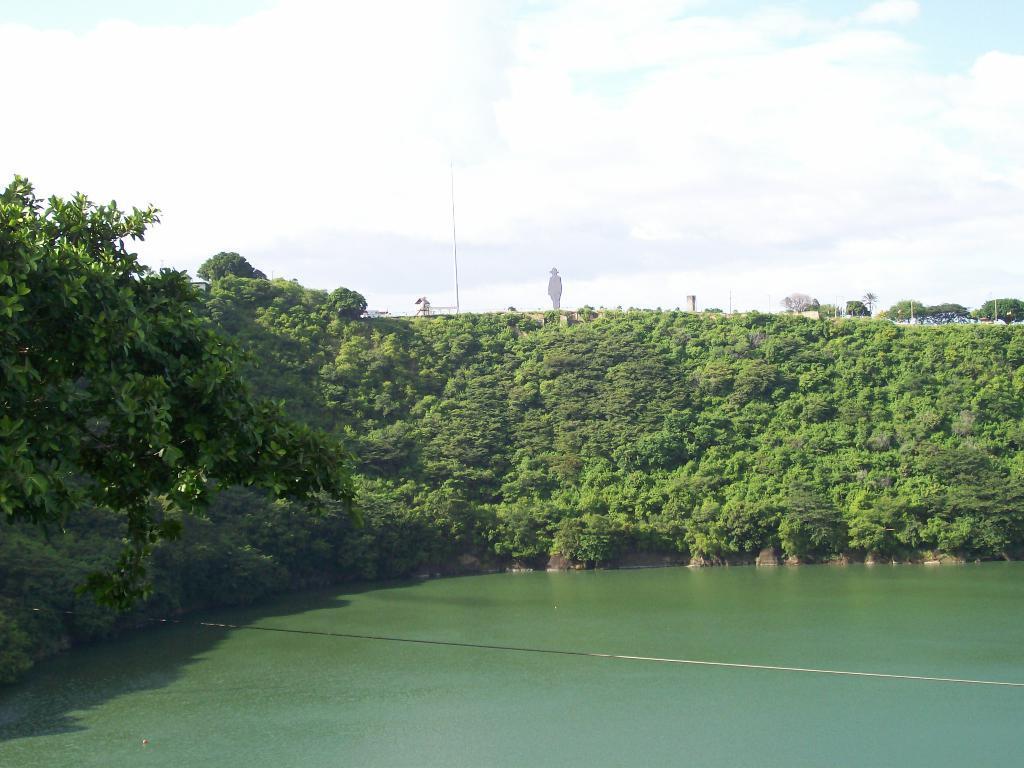How would you summarize this image in a sentence or two? In this image I can see the water. In the background I can see the plants, many trees, poles, clouds and the sky. 